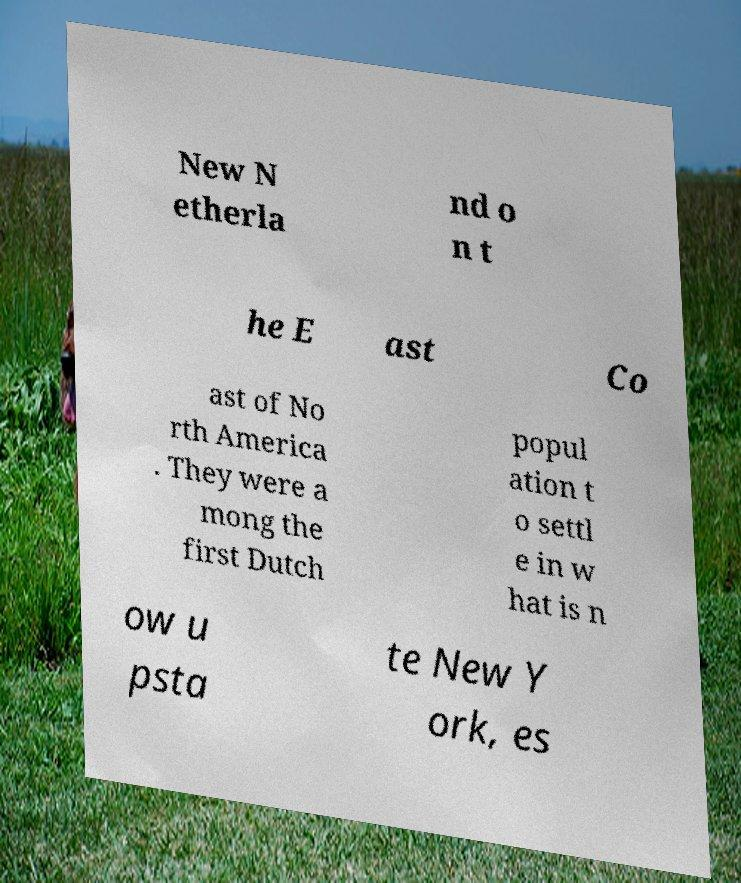What messages or text are displayed in this image? I need them in a readable, typed format. New N etherla nd o n t he E ast Co ast of No rth America . They were a mong the first Dutch popul ation t o settl e in w hat is n ow u psta te New Y ork, es 